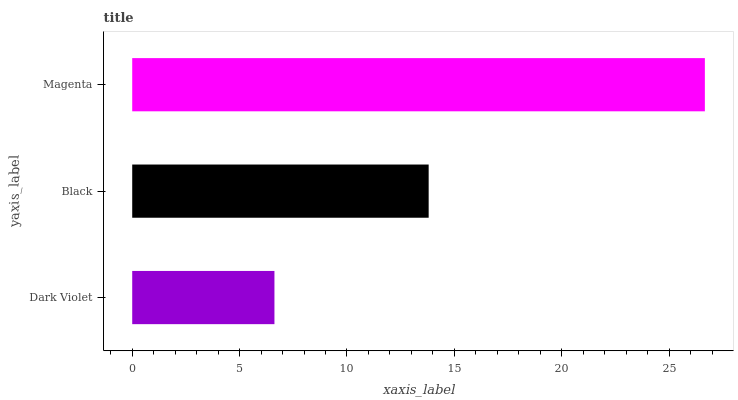Is Dark Violet the minimum?
Answer yes or no. Yes. Is Magenta the maximum?
Answer yes or no. Yes. Is Black the minimum?
Answer yes or no. No. Is Black the maximum?
Answer yes or no. No. Is Black greater than Dark Violet?
Answer yes or no. Yes. Is Dark Violet less than Black?
Answer yes or no. Yes. Is Dark Violet greater than Black?
Answer yes or no. No. Is Black less than Dark Violet?
Answer yes or no. No. Is Black the high median?
Answer yes or no. Yes. Is Black the low median?
Answer yes or no. Yes. Is Magenta the high median?
Answer yes or no. No. Is Dark Violet the low median?
Answer yes or no. No. 